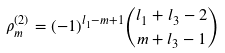Convert formula to latex. <formula><loc_0><loc_0><loc_500><loc_500>\rho ^ { ( 2 ) } _ { m } = ( - 1 ) ^ { l _ { 1 } - m + 1 } { l _ { 1 } + l _ { 3 } - 2 \choose m + l _ { 3 } - 1 }</formula> 